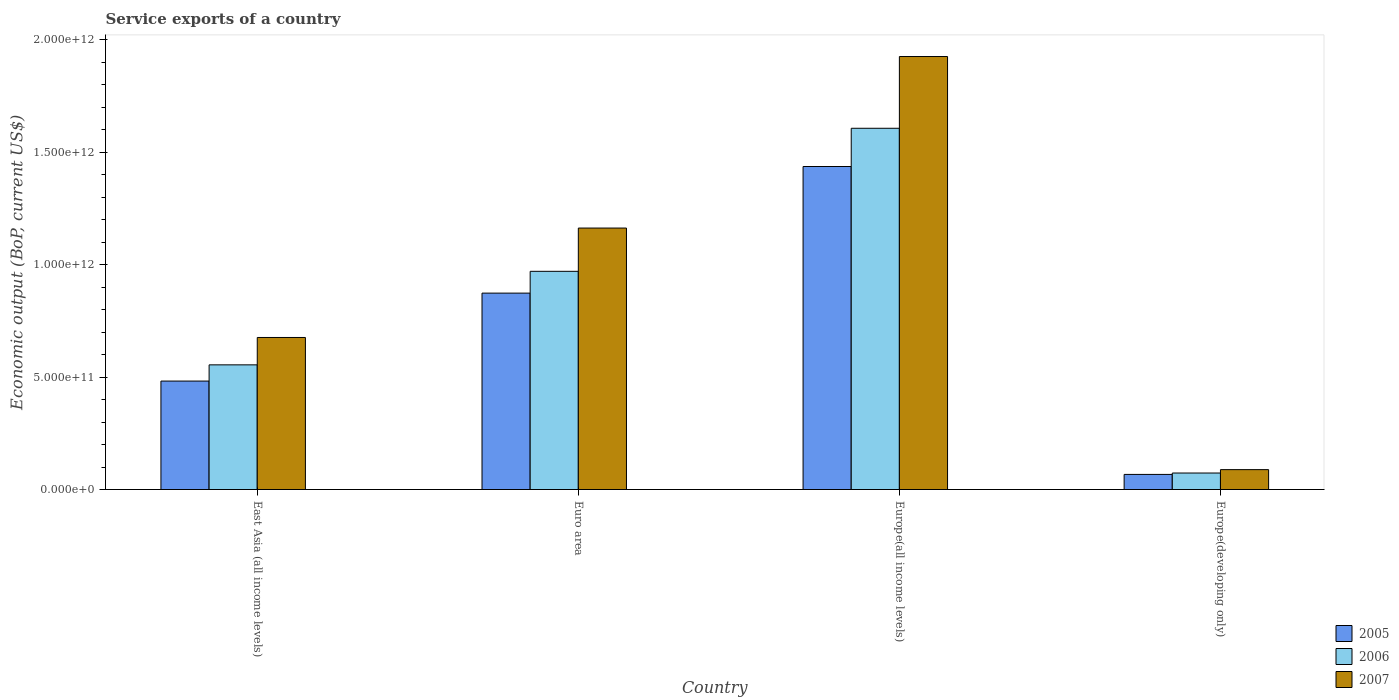Are the number of bars per tick equal to the number of legend labels?
Ensure brevity in your answer.  Yes. What is the label of the 4th group of bars from the left?
Make the answer very short. Europe(developing only). In how many cases, is the number of bars for a given country not equal to the number of legend labels?
Provide a short and direct response. 0. What is the service exports in 2007 in Euro area?
Offer a very short reply. 1.16e+12. Across all countries, what is the maximum service exports in 2005?
Keep it short and to the point. 1.44e+12. Across all countries, what is the minimum service exports in 2007?
Give a very brief answer. 8.84e+1. In which country was the service exports in 2005 maximum?
Keep it short and to the point. Europe(all income levels). In which country was the service exports in 2007 minimum?
Offer a very short reply. Europe(developing only). What is the total service exports in 2006 in the graph?
Ensure brevity in your answer.  3.21e+12. What is the difference between the service exports in 2007 in East Asia (all income levels) and that in Europe(developing only)?
Offer a very short reply. 5.88e+11. What is the difference between the service exports in 2007 in Europe(developing only) and the service exports in 2005 in Europe(all income levels)?
Ensure brevity in your answer.  -1.35e+12. What is the average service exports in 2006 per country?
Provide a succinct answer. 8.01e+11. What is the difference between the service exports of/in 2007 and service exports of/in 2005 in Euro area?
Give a very brief answer. 2.89e+11. What is the ratio of the service exports in 2007 in Euro area to that in Europe(all income levels)?
Offer a very short reply. 0.6. Is the difference between the service exports in 2007 in East Asia (all income levels) and Europe(developing only) greater than the difference between the service exports in 2005 in East Asia (all income levels) and Europe(developing only)?
Provide a short and direct response. Yes. What is the difference between the highest and the second highest service exports in 2007?
Keep it short and to the point. 4.87e+11. What is the difference between the highest and the lowest service exports in 2007?
Your answer should be compact. 1.84e+12. Is the sum of the service exports in 2006 in Europe(all income levels) and Europe(developing only) greater than the maximum service exports in 2007 across all countries?
Keep it short and to the point. No. What does the 1st bar from the left in Euro area represents?
Ensure brevity in your answer.  2005. How many bars are there?
Offer a terse response. 12. How many countries are there in the graph?
Provide a succinct answer. 4. What is the difference between two consecutive major ticks on the Y-axis?
Your answer should be compact. 5.00e+11. Does the graph contain any zero values?
Give a very brief answer. No. Where does the legend appear in the graph?
Provide a short and direct response. Bottom right. How many legend labels are there?
Make the answer very short. 3. What is the title of the graph?
Ensure brevity in your answer.  Service exports of a country. What is the label or title of the Y-axis?
Provide a succinct answer. Economic output (BoP, current US$). What is the Economic output (BoP, current US$) of 2005 in East Asia (all income levels)?
Make the answer very short. 4.82e+11. What is the Economic output (BoP, current US$) of 2006 in East Asia (all income levels)?
Provide a short and direct response. 5.54e+11. What is the Economic output (BoP, current US$) of 2007 in East Asia (all income levels)?
Provide a succinct answer. 6.76e+11. What is the Economic output (BoP, current US$) of 2005 in Euro area?
Your answer should be very brief. 8.74e+11. What is the Economic output (BoP, current US$) of 2006 in Euro area?
Ensure brevity in your answer.  9.70e+11. What is the Economic output (BoP, current US$) of 2007 in Euro area?
Your response must be concise. 1.16e+12. What is the Economic output (BoP, current US$) in 2005 in Europe(all income levels)?
Keep it short and to the point. 1.44e+12. What is the Economic output (BoP, current US$) of 2006 in Europe(all income levels)?
Give a very brief answer. 1.61e+12. What is the Economic output (BoP, current US$) in 2007 in Europe(all income levels)?
Provide a short and direct response. 1.93e+12. What is the Economic output (BoP, current US$) of 2005 in Europe(developing only)?
Give a very brief answer. 6.72e+1. What is the Economic output (BoP, current US$) in 2006 in Europe(developing only)?
Ensure brevity in your answer.  7.34e+1. What is the Economic output (BoP, current US$) in 2007 in Europe(developing only)?
Your answer should be very brief. 8.84e+1. Across all countries, what is the maximum Economic output (BoP, current US$) in 2005?
Make the answer very short. 1.44e+12. Across all countries, what is the maximum Economic output (BoP, current US$) in 2006?
Offer a very short reply. 1.61e+12. Across all countries, what is the maximum Economic output (BoP, current US$) of 2007?
Give a very brief answer. 1.93e+12. Across all countries, what is the minimum Economic output (BoP, current US$) in 2005?
Give a very brief answer. 6.72e+1. Across all countries, what is the minimum Economic output (BoP, current US$) of 2006?
Keep it short and to the point. 7.34e+1. Across all countries, what is the minimum Economic output (BoP, current US$) of 2007?
Provide a short and direct response. 8.84e+1. What is the total Economic output (BoP, current US$) of 2005 in the graph?
Give a very brief answer. 2.86e+12. What is the total Economic output (BoP, current US$) in 2006 in the graph?
Make the answer very short. 3.21e+12. What is the total Economic output (BoP, current US$) of 2007 in the graph?
Your response must be concise. 3.85e+12. What is the difference between the Economic output (BoP, current US$) of 2005 in East Asia (all income levels) and that in Euro area?
Provide a short and direct response. -3.91e+11. What is the difference between the Economic output (BoP, current US$) of 2006 in East Asia (all income levels) and that in Euro area?
Offer a very short reply. -4.16e+11. What is the difference between the Economic output (BoP, current US$) in 2007 in East Asia (all income levels) and that in Euro area?
Your response must be concise. -4.87e+11. What is the difference between the Economic output (BoP, current US$) in 2005 in East Asia (all income levels) and that in Europe(all income levels)?
Offer a terse response. -9.54e+11. What is the difference between the Economic output (BoP, current US$) in 2006 in East Asia (all income levels) and that in Europe(all income levels)?
Give a very brief answer. -1.05e+12. What is the difference between the Economic output (BoP, current US$) of 2007 in East Asia (all income levels) and that in Europe(all income levels)?
Provide a short and direct response. -1.25e+12. What is the difference between the Economic output (BoP, current US$) of 2005 in East Asia (all income levels) and that in Europe(developing only)?
Provide a short and direct response. 4.15e+11. What is the difference between the Economic output (BoP, current US$) of 2006 in East Asia (all income levels) and that in Europe(developing only)?
Ensure brevity in your answer.  4.81e+11. What is the difference between the Economic output (BoP, current US$) in 2007 in East Asia (all income levels) and that in Europe(developing only)?
Keep it short and to the point. 5.88e+11. What is the difference between the Economic output (BoP, current US$) of 2005 in Euro area and that in Europe(all income levels)?
Give a very brief answer. -5.63e+11. What is the difference between the Economic output (BoP, current US$) in 2006 in Euro area and that in Europe(all income levels)?
Your answer should be compact. -6.36e+11. What is the difference between the Economic output (BoP, current US$) in 2007 in Euro area and that in Europe(all income levels)?
Make the answer very short. -7.63e+11. What is the difference between the Economic output (BoP, current US$) in 2005 in Euro area and that in Europe(developing only)?
Offer a terse response. 8.06e+11. What is the difference between the Economic output (BoP, current US$) in 2006 in Euro area and that in Europe(developing only)?
Provide a short and direct response. 8.97e+11. What is the difference between the Economic output (BoP, current US$) in 2007 in Euro area and that in Europe(developing only)?
Offer a very short reply. 1.07e+12. What is the difference between the Economic output (BoP, current US$) in 2005 in Europe(all income levels) and that in Europe(developing only)?
Your answer should be very brief. 1.37e+12. What is the difference between the Economic output (BoP, current US$) of 2006 in Europe(all income levels) and that in Europe(developing only)?
Make the answer very short. 1.53e+12. What is the difference between the Economic output (BoP, current US$) in 2007 in Europe(all income levels) and that in Europe(developing only)?
Your response must be concise. 1.84e+12. What is the difference between the Economic output (BoP, current US$) in 2005 in East Asia (all income levels) and the Economic output (BoP, current US$) in 2006 in Euro area?
Make the answer very short. -4.88e+11. What is the difference between the Economic output (BoP, current US$) in 2005 in East Asia (all income levels) and the Economic output (BoP, current US$) in 2007 in Euro area?
Provide a succinct answer. -6.81e+11. What is the difference between the Economic output (BoP, current US$) of 2006 in East Asia (all income levels) and the Economic output (BoP, current US$) of 2007 in Euro area?
Give a very brief answer. -6.08e+11. What is the difference between the Economic output (BoP, current US$) of 2005 in East Asia (all income levels) and the Economic output (BoP, current US$) of 2006 in Europe(all income levels)?
Give a very brief answer. -1.12e+12. What is the difference between the Economic output (BoP, current US$) in 2005 in East Asia (all income levels) and the Economic output (BoP, current US$) in 2007 in Europe(all income levels)?
Offer a terse response. -1.44e+12. What is the difference between the Economic output (BoP, current US$) of 2006 in East Asia (all income levels) and the Economic output (BoP, current US$) of 2007 in Europe(all income levels)?
Your answer should be very brief. -1.37e+12. What is the difference between the Economic output (BoP, current US$) in 2005 in East Asia (all income levels) and the Economic output (BoP, current US$) in 2006 in Europe(developing only)?
Provide a short and direct response. 4.09e+11. What is the difference between the Economic output (BoP, current US$) of 2005 in East Asia (all income levels) and the Economic output (BoP, current US$) of 2007 in Europe(developing only)?
Your answer should be very brief. 3.94e+11. What is the difference between the Economic output (BoP, current US$) of 2006 in East Asia (all income levels) and the Economic output (BoP, current US$) of 2007 in Europe(developing only)?
Give a very brief answer. 4.66e+11. What is the difference between the Economic output (BoP, current US$) of 2005 in Euro area and the Economic output (BoP, current US$) of 2006 in Europe(all income levels)?
Ensure brevity in your answer.  -7.33e+11. What is the difference between the Economic output (BoP, current US$) of 2005 in Euro area and the Economic output (BoP, current US$) of 2007 in Europe(all income levels)?
Keep it short and to the point. -1.05e+12. What is the difference between the Economic output (BoP, current US$) of 2006 in Euro area and the Economic output (BoP, current US$) of 2007 in Europe(all income levels)?
Offer a very short reply. -9.55e+11. What is the difference between the Economic output (BoP, current US$) of 2005 in Euro area and the Economic output (BoP, current US$) of 2006 in Europe(developing only)?
Give a very brief answer. 8.00e+11. What is the difference between the Economic output (BoP, current US$) in 2005 in Euro area and the Economic output (BoP, current US$) in 2007 in Europe(developing only)?
Your answer should be very brief. 7.85e+11. What is the difference between the Economic output (BoP, current US$) in 2006 in Euro area and the Economic output (BoP, current US$) in 2007 in Europe(developing only)?
Your answer should be compact. 8.82e+11. What is the difference between the Economic output (BoP, current US$) of 2005 in Europe(all income levels) and the Economic output (BoP, current US$) of 2006 in Europe(developing only)?
Provide a short and direct response. 1.36e+12. What is the difference between the Economic output (BoP, current US$) of 2005 in Europe(all income levels) and the Economic output (BoP, current US$) of 2007 in Europe(developing only)?
Your answer should be compact. 1.35e+12. What is the difference between the Economic output (BoP, current US$) of 2006 in Europe(all income levels) and the Economic output (BoP, current US$) of 2007 in Europe(developing only)?
Your response must be concise. 1.52e+12. What is the average Economic output (BoP, current US$) of 2005 per country?
Give a very brief answer. 7.15e+11. What is the average Economic output (BoP, current US$) of 2006 per country?
Provide a succinct answer. 8.01e+11. What is the average Economic output (BoP, current US$) of 2007 per country?
Offer a very short reply. 9.63e+11. What is the difference between the Economic output (BoP, current US$) of 2005 and Economic output (BoP, current US$) of 2006 in East Asia (all income levels)?
Ensure brevity in your answer.  -7.21e+1. What is the difference between the Economic output (BoP, current US$) of 2005 and Economic output (BoP, current US$) of 2007 in East Asia (all income levels)?
Your answer should be very brief. -1.94e+11. What is the difference between the Economic output (BoP, current US$) in 2006 and Economic output (BoP, current US$) in 2007 in East Asia (all income levels)?
Your answer should be compact. -1.22e+11. What is the difference between the Economic output (BoP, current US$) in 2005 and Economic output (BoP, current US$) in 2006 in Euro area?
Keep it short and to the point. -9.69e+1. What is the difference between the Economic output (BoP, current US$) of 2005 and Economic output (BoP, current US$) of 2007 in Euro area?
Offer a very short reply. -2.89e+11. What is the difference between the Economic output (BoP, current US$) in 2006 and Economic output (BoP, current US$) in 2007 in Euro area?
Offer a terse response. -1.92e+11. What is the difference between the Economic output (BoP, current US$) in 2005 and Economic output (BoP, current US$) in 2006 in Europe(all income levels)?
Offer a very short reply. -1.70e+11. What is the difference between the Economic output (BoP, current US$) in 2005 and Economic output (BoP, current US$) in 2007 in Europe(all income levels)?
Make the answer very short. -4.89e+11. What is the difference between the Economic output (BoP, current US$) in 2006 and Economic output (BoP, current US$) in 2007 in Europe(all income levels)?
Offer a very short reply. -3.19e+11. What is the difference between the Economic output (BoP, current US$) in 2005 and Economic output (BoP, current US$) in 2006 in Europe(developing only)?
Offer a very short reply. -6.16e+09. What is the difference between the Economic output (BoP, current US$) of 2005 and Economic output (BoP, current US$) of 2007 in Europe(developing only)?
Provide a short and direct response. -2.12e+1. What is the difference between the Economic output (BoP, current US$) in 2006 and Economic output (BoP, current US$) in 2007 in Europe(developing only)?
Give a very brief answer. -1.50e+1. What is the ratio of the Economic output (BoP, current US$) of 2005 in East Asia (all income levels) to that in Euro area?
Give a very brief answer. 0.55. What is the ratio of the Economic output (BoP, current US$) of 2007 in East Asia (all income levels) to that in Euro area?
Offer a very short reply. 0.58. What is the ratio of the Economic output (BoP, current US$) in 2005 in East Asia (all income levels) to that in Europe(all income levels)?
Offer a very short reply. 0.34. What is the ratio of the Economic output (BoP, current US$) in 2006 in East Asia (all income levels) to that in Europe(all income levels)?
Offer a very short reply. 0.35. What is the ratio of the Economic output (BoP, current US$) in 2007 in East Asia (all income levels) to that in Europe(all income levels)?
Make the answer very short. 0.35. What is the ratio of the Economic output (BoP, current US$) in 2005 in East Asia (all income levels) to that in Europe(developing only)?
Provide a succinct answer. 7.18. What is the ratio of the Economic output (BoP, current US$) of 2006 in East Asia (all income levels) to that in Europe(developing only)?
Provide a short and direct response. 7.56. What is the ratio of the Economic output (BoP, current US$) of 2007 in East Asia (all income levels) to that in Europe(developing only)?
Keep it short and to the point. 7.65. What is the ratio of the Economic output (BoP, current US$) of 2005 in Euro area to that in Europe(all income levels)?
Provide a succinct answer. 0.61. What is the ratio of the Economic output (BoP, current US$) in 2006 in Euro area to that in Europe(all income levels)?
Provide a short and direct response. 0.6. What is the ratio of the Economic output (BoP, current US$) of 2007 in Euro area to that in Europe(all income levels)?
Your answer should be very brief. 0.6. What is the ratio of the Economic output (BoP, current US$) of 2005 in Euro area to that in Europe(developing only)?
Provide a succinct answer. 13. What is the ratio of the Economic output (BoP, current US$) in 2006 in Euro area to that in Europe(developing only)?
Provide a short and direct response. 13.23. What is the ratio of the Economic output (BoP, current US$) in 2007 in Euro area to that in Europe(developing only)?
Offer a very short reply. 13.15. What is the ratio of the Economic output (BoP, current US$) in 2005 in Europe(all income levels) to that in Europe(developing only)?
Give a very brief answer. 21.38. What is the ratio of the Economic output (BoP, current US$) in 2006 in Europe(all income levels) to that in Europe(developing only)?
Make the answer very short. 21.9. What is the ratio of the Economic output (BoP, current US$) of 2007 in Europe(all income levels) to that in Europe(developing only)?
Ensure brevity in your answer.  21.78. What is the difference between the highest and the second highest Economic output (BoP, current US$) in 2005?
Give a very brief answer. 5.63e+11. What is the difference between the highest and the second highest Economic output (BoP, current US$) of 2006?
Your answer should be compact. 6.36e+11. What is the difference between the highest and the second highest Economic output (BoP, current US$) in 2007?
Offer a very short reply. 7.63e+11. What is the difference between the highest and the lowest Economic output (BoP, current US$) of 2005?
Offer a terse response. 1.37e+12. What is the difference between the highest and the lowest Economic output (BoP, current US$) of 2006?
Make the answer very short. 1.53e+12. What is the difference between the highest and the lowest Economic output (BoP, current US$) in 2007?
Your answer should be compact. 1.84e+12. 